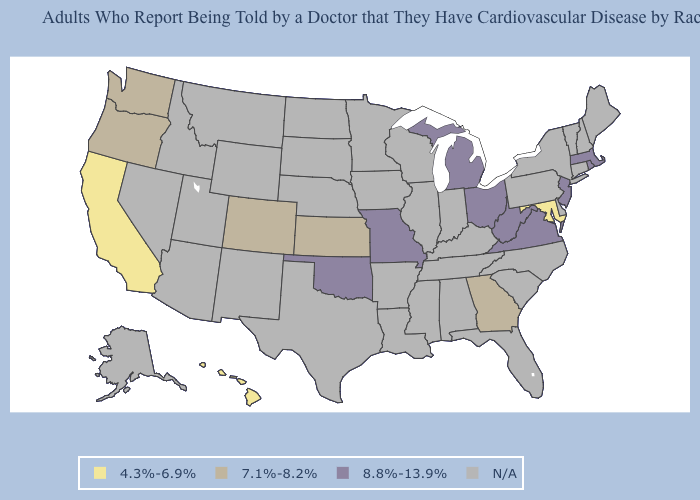What is the lowest value in the MidWest?
Give a very brief answer. 7.1%-8.2%. Among the states that border Kansas , does Oklahoma have the highest value?
Keep it brief. Yes. What is the value of Minnesota?
Answer briefly. N/A. Does the first symbol in the legend represent the smallest category?
Be succinct. Yes. Among the states that border Arizona , which have the highest value?
Quick response, please. Colorado. Among the states that border Illinois , which have the highest value?
Write a very short answer. Missouri. Name the states that have a value in the range 8.8%-13.9%?
Write a very short answer. Massachusetts, Michigan, Missouri, New Jersey, Ohio, Oklahoma, Rhode Island, Virginia, West Virginia. What is the value of Missouri?
Concise answer only. 8.8%-13.9%. What is the value of South Carolina?
Keep it brief. N/A. Name the states that have a value in the range 7.1%-8.2%?
Give a very brief answer. Colorado, Georgia, Kansas, Oregon, Washington. Name the states that have a value in the range 4.3%-6.9%?
Quick response, please. California, Hawaii, Maryland. Does Colorado have the highest value in the USA?
Keep it brief. No. Does California have the lowest value in the USA?
Give a very brief answer. Yes. What is the highest value in states that border New Hampshire?
Write a very short answer. 8.8%-13.9%. 